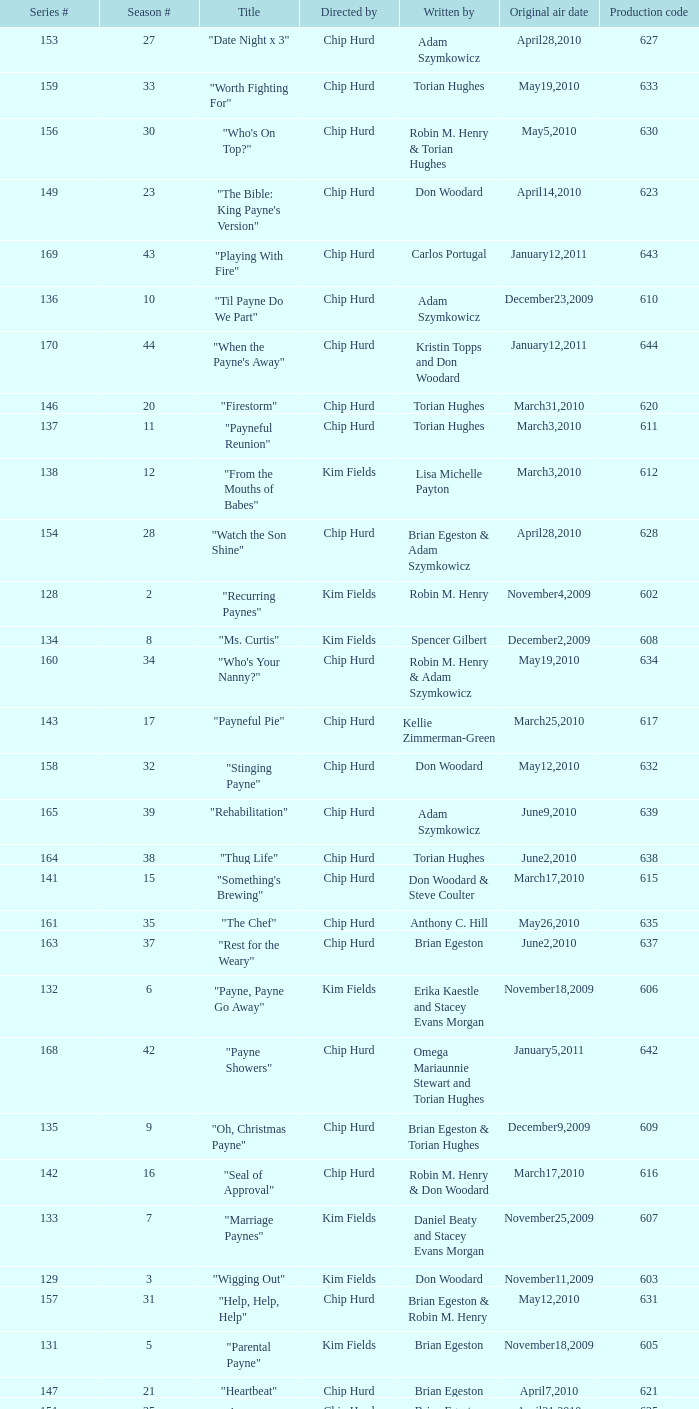What is the title of the episode with the production code 624? "Matured Investment". 